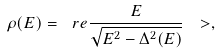<formula> <loc_0><loc_0><loc_500><loc_500>\rho ( E ) = \ r e \frac { E } { \sqrt { E ^ { 2 } - \Delta ^ { 2 } ( E ) } } \ > ,</formula> 